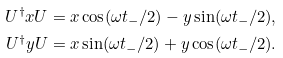<formula> <loc_0><loc_0><loc_500><loc_500>U ^ { \dagger } x U & = x \cos ( \omega t _ { - } / 2 ) - y \sin ( \omega t _ { - } / 2 ) , \\ U ^ { \dagger } y U & = x \sin ( \omega t _ { - } / 2 ) + y \cos ( \omega t _ { - } / 2 ) .</formula> 